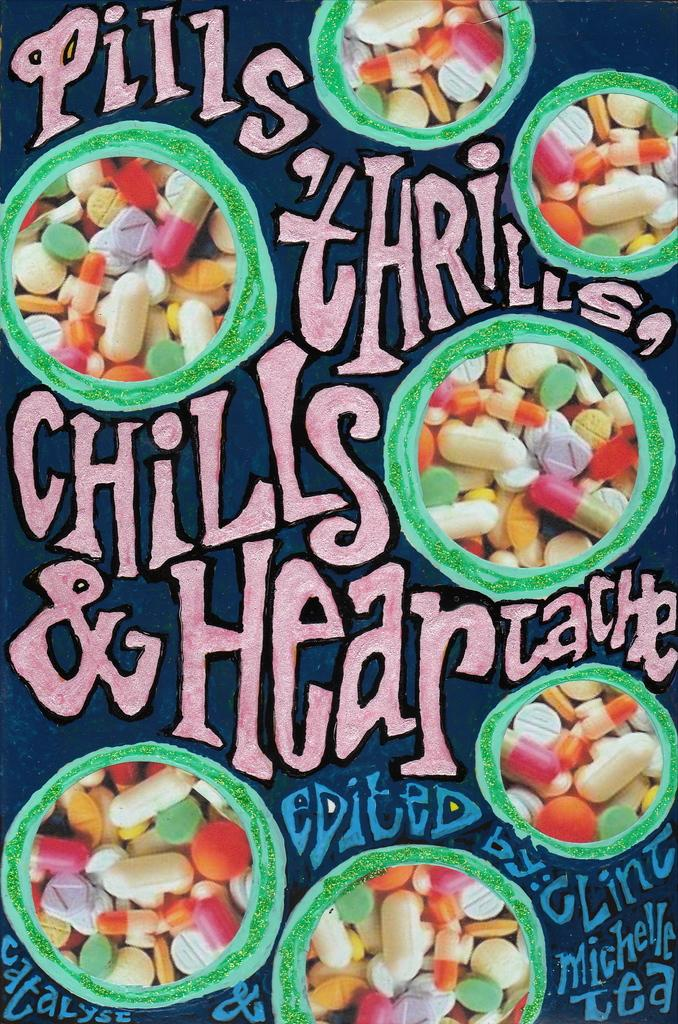What type of visual is the image? The image is a poster. What items are depicted in the poster? There are capsules and tablets in the image. Are there any written elements in the poster? Yes, there are different texts in the image. What type of mint is shown growing in the image? There is no mint plant or any type of plant visible in the image; it features capsules, tablets, and texts. 